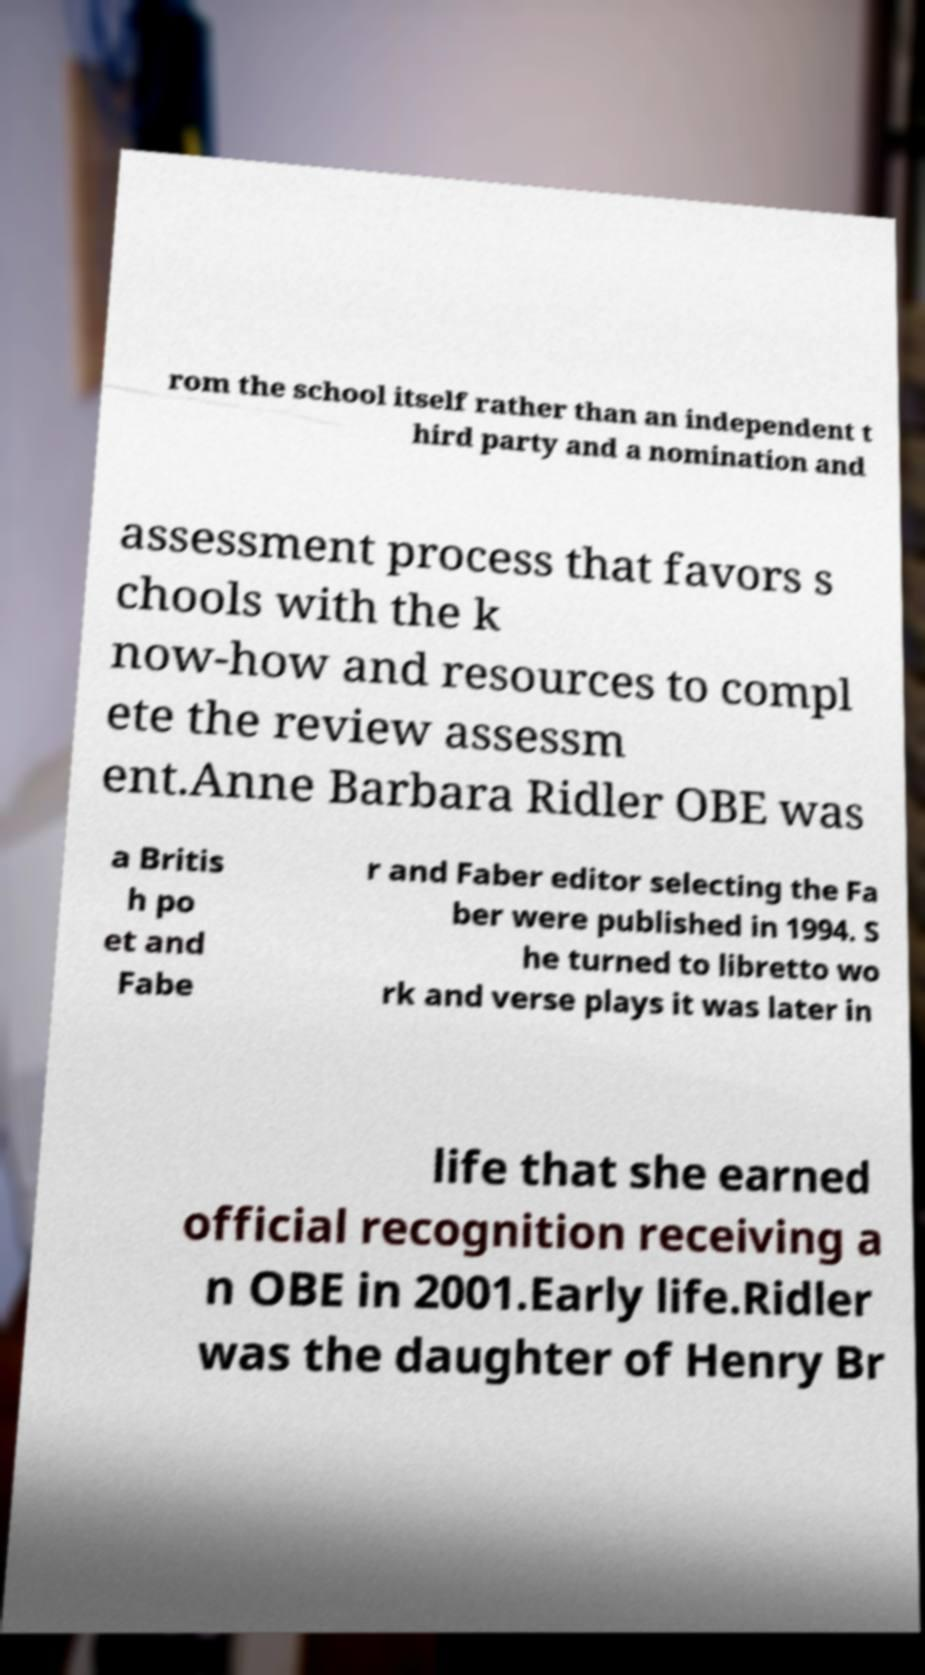Please read and relay the text visible in this image. What does it say? rom the school itself rather than an independent t hird party and a nomination and assessment process that favors s chools with the k now-how and resources to compl ete the review assessm ent.Anne Barbara Ridler OBE was a Britis h po et and Fabe r and Faber editor selecting the Fa ber were published in 1994. S he turned to libretto wo rk and verse plays it was later in life that she earned official recognition receiving a n OBE in 2001.Early life.Ridler was the daughter of Henry Br 